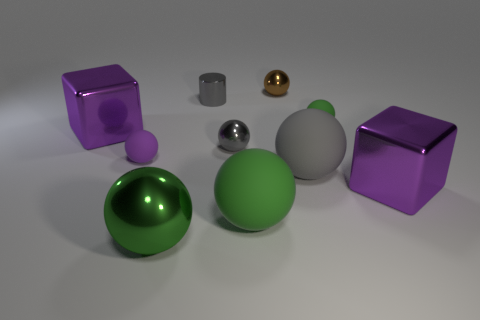There is a large matte thing that is the same color as the cylinder; what shape is it?
Offer a terse response. Sphere. Do the tiny matte sphere to the right of the big green rubber thing and the big shiny ball have the same color?
Offer a terse response. Yes. Is there anything else of the same color as the cylinder?
Make the answer very short. Yes. Does the brown object have the same size as the gray rubber object?
Provide a succinct answer. No. There is a tiny green object that is the same shape as the tiny brown object; what is its material?
Give a very brief answer. Rubber. Are there any other things that have the same material as the big gray sphere?
Give a very brief answer. Yes. What number of cyan things are either tiny matte spheres or tiny cylinders?
Keep it short and to the point. 0. There is a large purple thing to the right of the small brown thing; what is it made of?
Provide a short and direct response. Metal. Are there more tiny purple rubber objects than large red metallic cubes?
Your answer should be compact. Yes. Is the shape of the tiny matte thing right of the gray matte object the same as  the small purple rubber object?
Your answer should be very brief. Yes. 